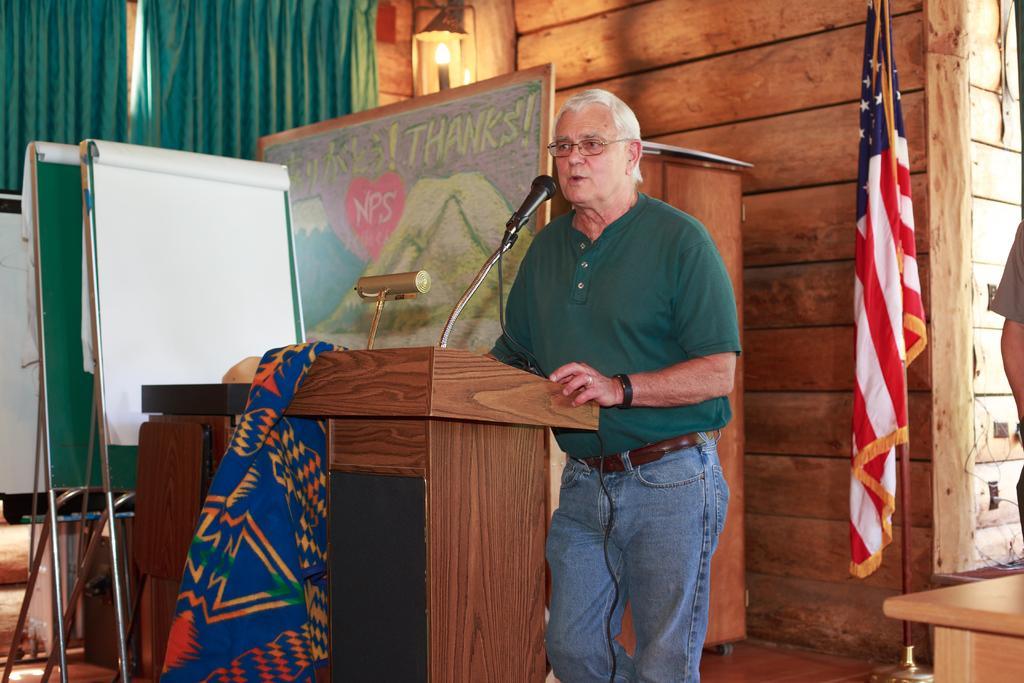In one or two sentences, can you explain what this image depicts? In the center of the image we can see person standing at the desk. On the desk we can see mic. In the background we can see flag, person, wall, board, light and curtain. 